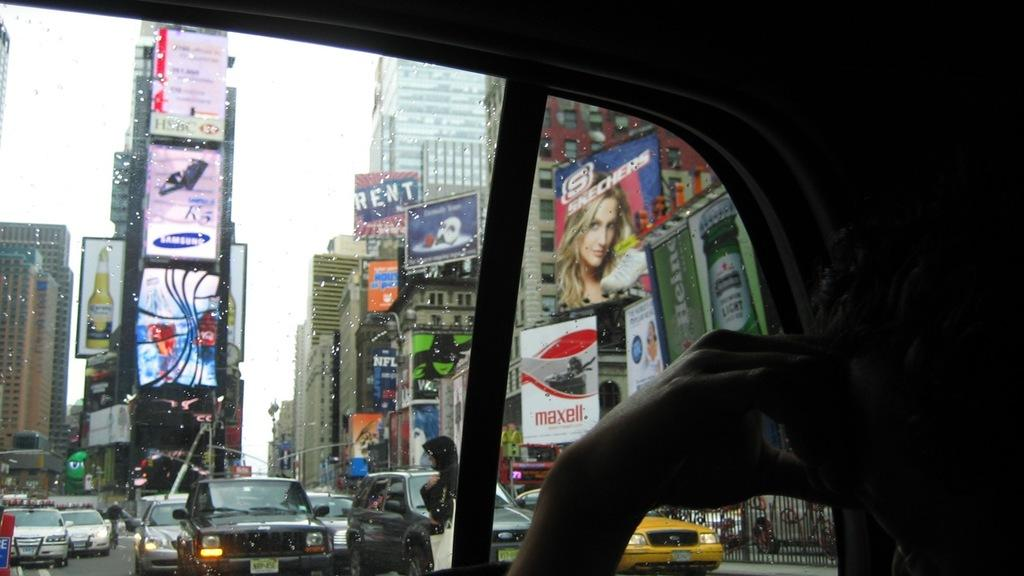<image>
Write a terse but informative summary of the picture. A city view out of a vehicle window where a billboard for Rent and Maxell, among others, can be seen. 